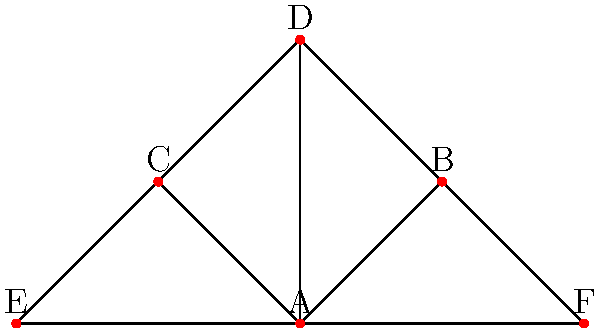In the network graph representing marriage connections between noble families of Luxemburg, Family A appears to be a central node. How many families are directly connected to Family A through marriage, and what does this suggest about Family A's influence in the noble social network? To answer this question, we need to analyze the network graph and follow these steps:

1. Identify Family A in the graph:
   Family A is represented by the central node labeled "A".

2. Count the number of direct connections to Family A:
   - Family A is directly connected to Family B
   - Family A is directly connected to Family C
   - Family A is directly connected to Family D
   - Family A is directly connected to Family E
   - Family A is directly connected to Family F

3. Sum up the total number of direct connections:
   Family A has 5 direct connections.

4. Interpret the significance:
   The high number of direct connections suggests that Family A has a central and influential position in the noble social network of Luxemburg. This could indicate that:
   - Family A has been strategically forming alliances through marriages.
   - They likely hold significant political or economic power.
   - They may act as a bridge between different family groups.
   - Their centrality could make them key players in diplomatic negotiations or succession disputes.

This central position in the marriage network implies that Family A has likely been one of the most influential noble families in Luxemburg's history.
Answer: 5 direct connections; highly influential central position 